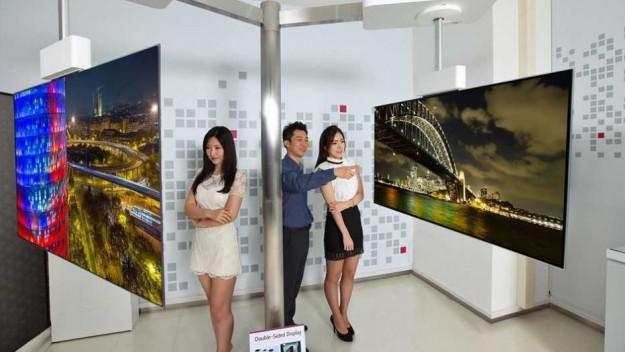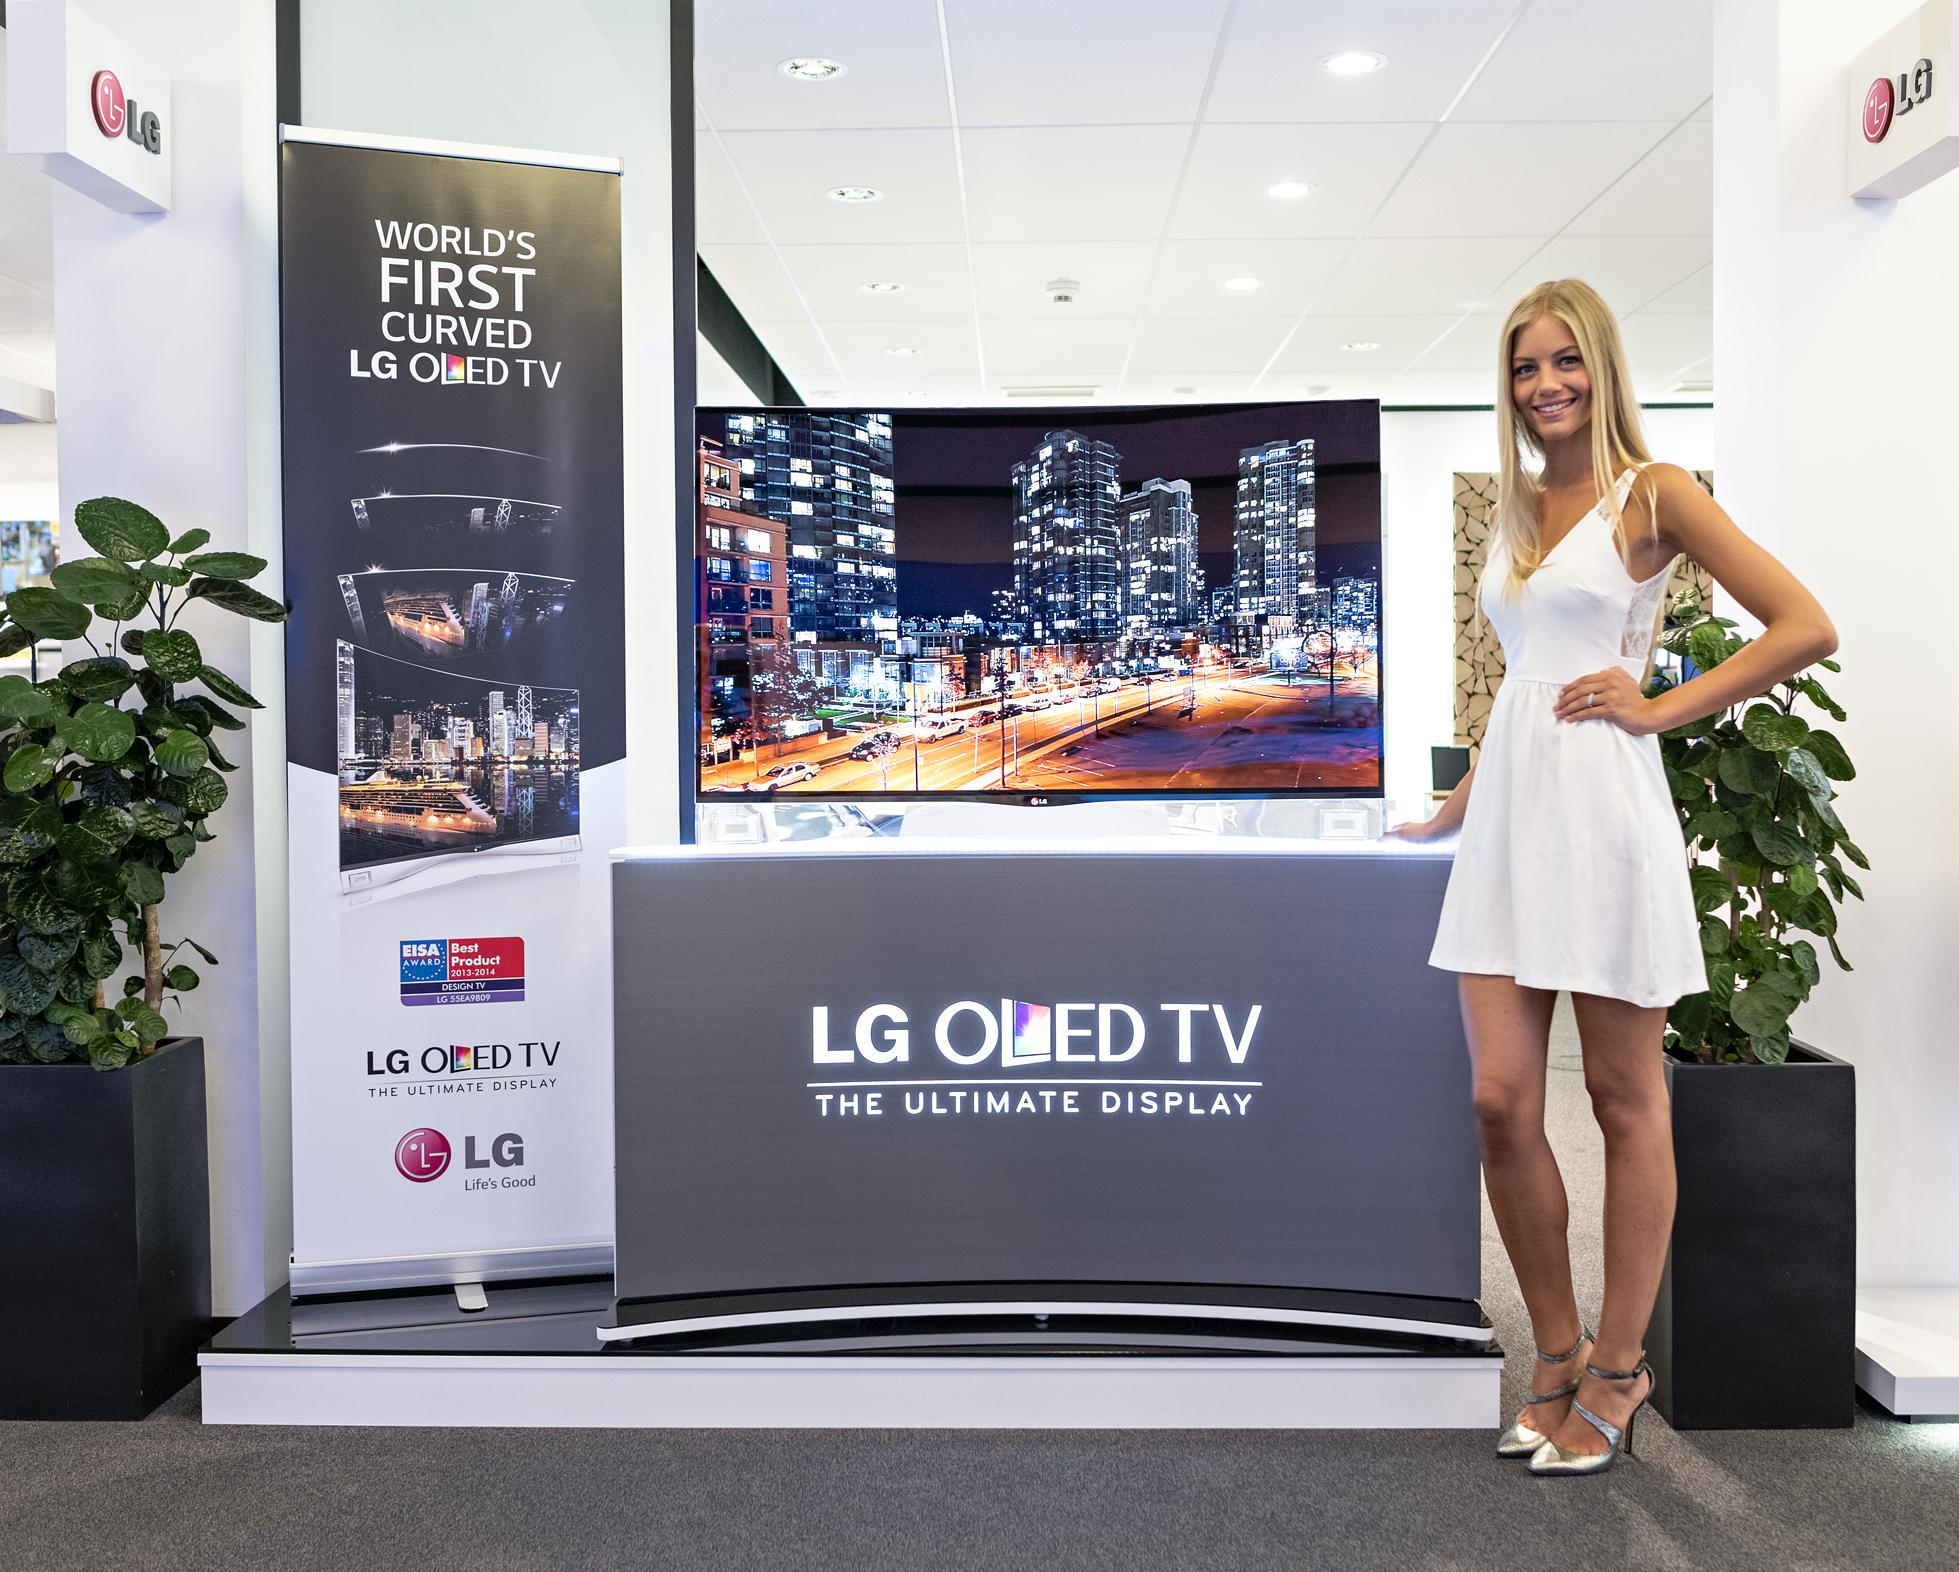The first image is the image on the left, the second image is the image on the right. Analyze the images presented: Is the assertion "There are no women featured in any of the images." valid? Answer yes or no. No. The first image is the image on the left, the second image is the image on the right. Assess this claim about the two images: "Atleast one image contains a computer monitor.". Correct or not? Answer yes or no. No. 